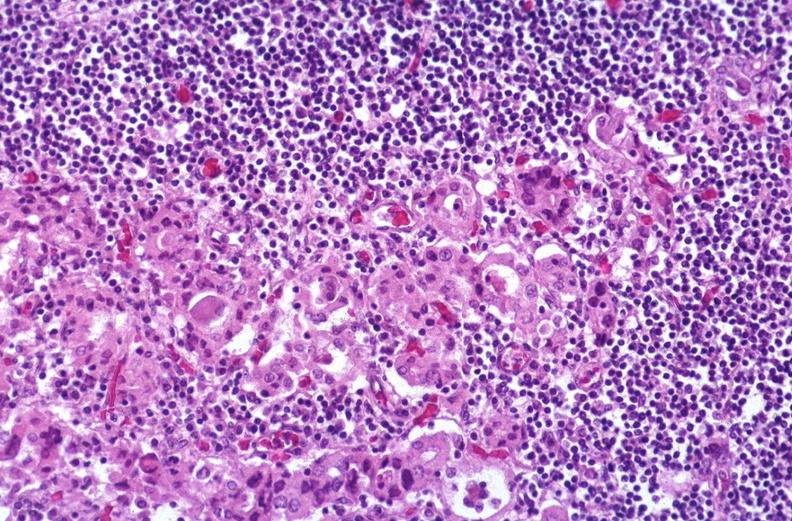where is this part in the figure?
Answer the question using a single word or phrase. Endocrine system 